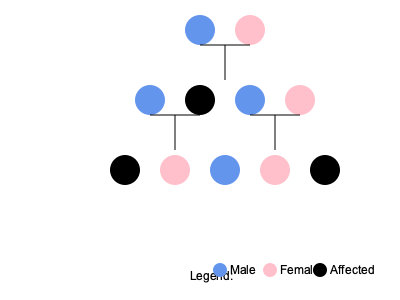Based on the pedigree chart shown, what is the most likely inheritance pattern for the genetic condition affecting this family? How does this information relate to the potential risk for your unborn child? To determine the inheritance pattern and assess the risk for your unborn child, let's analyze the pedigree chart step-by-step:

1. Observe the affected individuals:
   - Generation II: One affected female
   - Generation III: Two affected males

2. Key characteristics to consider:
   a) The condition appears in both males and females.
   b) It doesn't affect every generation (skips Generation I).
   c) Affected individuals have at least one unaffected parent.

3. Eliminate inheritance patterns:
   - X-linked recessive: Ruled out because females are affected.
   - X-linked dominant: Unlikely, as affected fathers would pass it to all daughters.
   - Y-linked: Ruled out because females are affected.
   - Mitochondrial: Ruled out because it's passed from mother to all children.

4. Most likely pattern: Autosomal dominant
   - Explains affected individuals in multiple generations
   - Explains how it can affect both males and females
   - Consistent with the pattern of affected offspring from unaffected parents (due to reduced penetrance or new mutations)

5. Risk assessment for your unborn child:
   - If you or your partner is affected: 50% chance of passing the gene to the child.
   - If neither you nor your partner is affected: Risk is low but not zero (due to possible reduced penetrance or new mutations).

6. Important considerations:
   - Penetrance may be incomplete, meaning not everyone with the gene shows symptoms.
   - Age of onset may vary, so apparently unaffected individuals might develop symptoms later.

This analysis provides a framework for understanding the genetic risks, but for a definitive assessment, genetic counseling and testing are recommended.
Answer: Autosomal dominant inheritance; 50% risk if a parent is affected, low risk if neither parent is affected. 